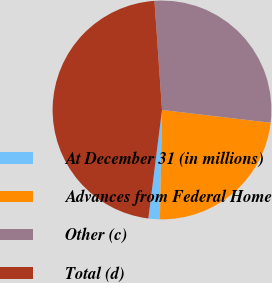Convert chart to OTSL. <chart><loc_0><loc_0><loc_500><loc_500><pie_chart><fcel>At December 31 (in millions)<fcel>Advances from Federal Home<fcel>Other (c)<fcel>Total (d)<nl><fcel>1.69%<fcel>23.44%<fcel>27.96%<fcel>46.91%<nl></chart> 